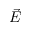<formula> <loc_0><loc_0><loc_500><loc_500>\vec { E }</formula> 